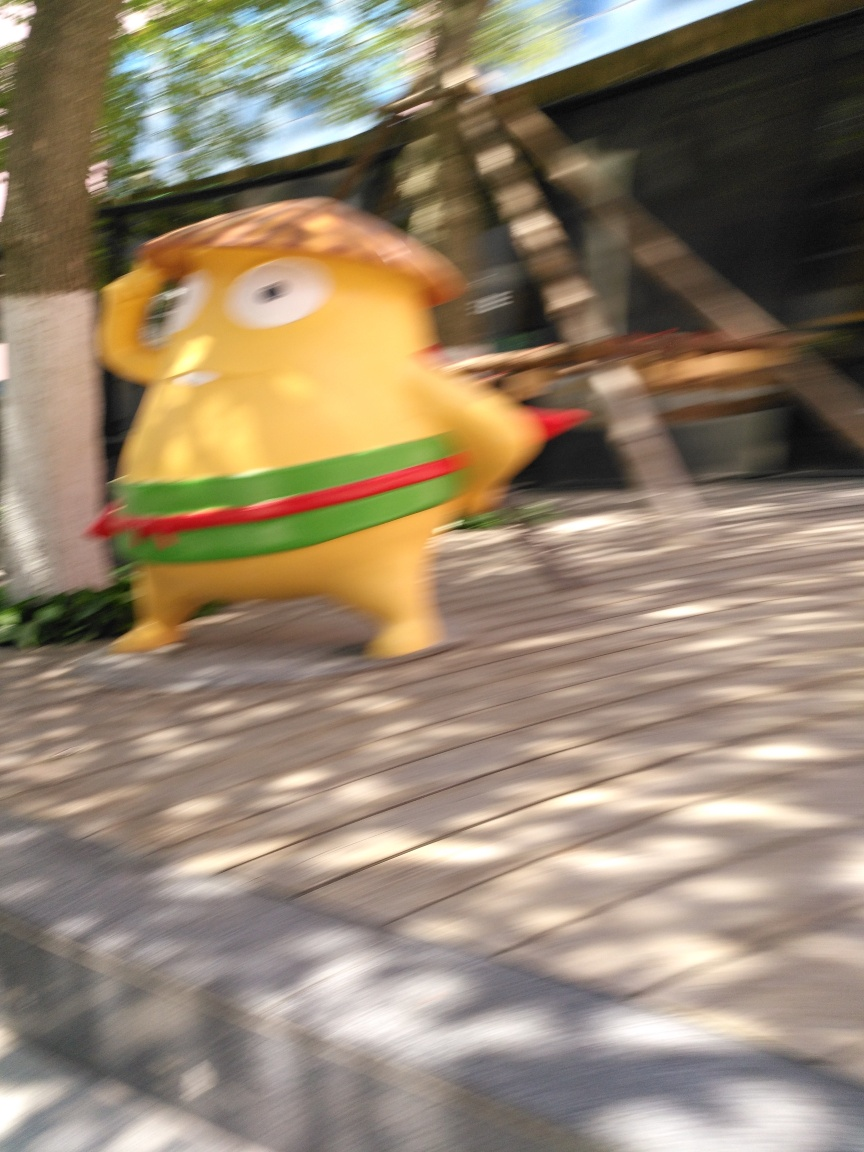What’s creating the blurred effect in this photo? The blurred effect is likely due to a combination of the subject's rapid movement and a slower camera shutter speed, resulting in motion blur that conveys a sense of speed and movement. 